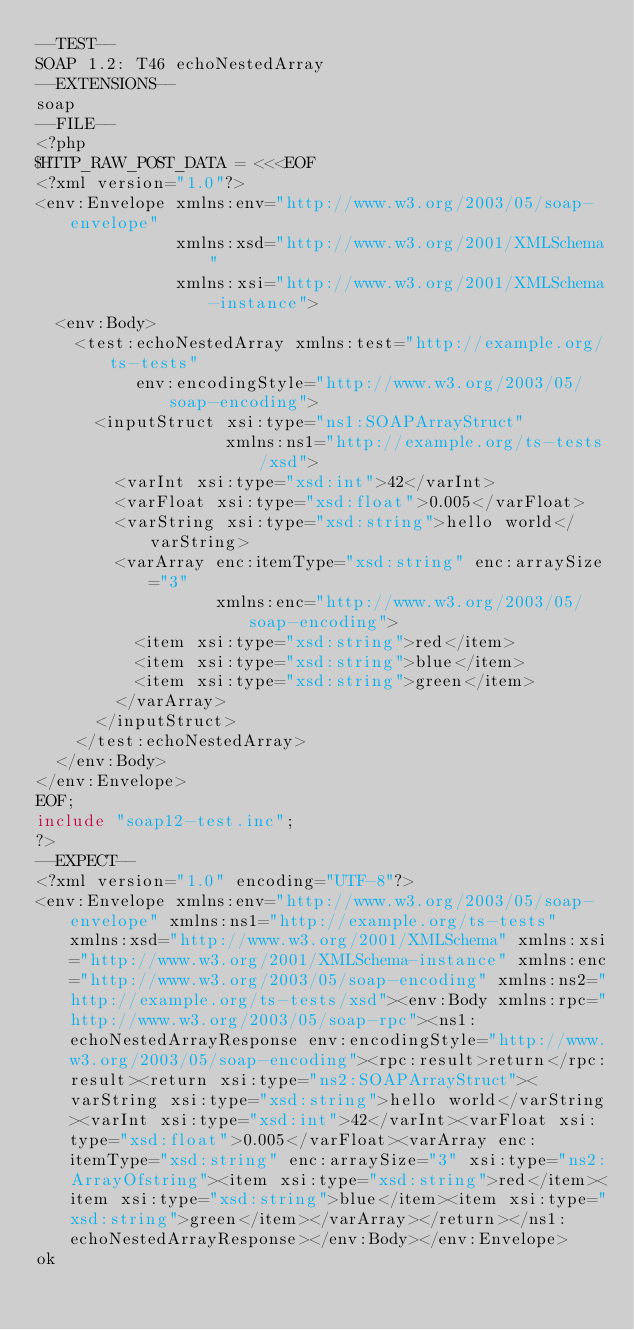<code> <loc_0><loc_0><loc_500><loc_500><_PHP_>--TEST--
SOAP 1.2: T46 echoNestedArray
--EXTENSIONS--
soap
--FILE--
<?php
$HTTP_RAW_POST_DATA = <<<EOF
<?xml version="1.0"?>
<env:Envelope xmlns:env="http://www.w3.org/2003/05/soap-envelope"
              xmlns:xsd="http://www.w3.org/2001/XMLSchema"
              xmlns:xsi="http://www.w3.org/2001/XMLSchema-instance">
  <env:Body>
    <test:echoNestedArray xmlns:test="http://example.org/ts-tests"
          env:encodingStyle="http://www.w3.org/2003/05/soap-encoding">
      <inputStruct xsi:type="ns1:SOAPArrayStruct"
                   xmlns:ns1="http://example.org/ts-tests/xsd">
        <varInt xsi:type="xsd:int">42</varInt>
        <varFloat xsi:type="xsd:float">0.005</varFloat>
        <varString xsi:type="xsd:string">hello world</varString>
        <varArray enc:itemType="xsd:string" enc:arraySize="3"
                  xmlns:enc="http://www.w3.org/2003/05/soap-encoding">
          <item xsi:type="xsd:string">red</item>
          <item xsi:type="xsd:string">blue</item>
          <item xsi:type="xsd:string">green</item>
        </varArray>
      </inputStruct>
    </test:echoNestedArray>
  </env:Body>
</env:Envelope>
EOF;
include "soap12-test.inc";
?>
--EXPECT--
<?xml version="1.0" encoding="UTF-8"?>
<env:Envelope xmlns:env="http://www.w3.org/2003/05/soap-envelope" xmlns:ns1="http://example.org/ts-tests" xmlns:xsd="http://www.w3.org/2001/XMLSchema" xmlns:xsi="http://www.w3.org/2001/XMLSchema-instance" xmlns:enc="http://www.w3.org/2003/05/soap-encoding" xmlns:ns2="http://example.org/ts-tests/xsd"><env:Body xmlns:rpc="http://www.w3.org/2003/05/soap-rpc"><ns1:echoNestedArrayResponse env:encodingStyle="http://www.w3.org/2003/05/soap-encoding"><rpc:result>return</rpc:result><return xsi:type="ns2:SOAPArrayStruct"><varString xsi:type="xsd:string">hello world</varString><varInt xsi:type="xsd:int">42</varInt><varFloat xsi:type="xsd:float">0.005</varFloat><varArray enc:itemType="xsd:string" enc:arraySize="3" xsi:type="ns2:ArrayOfstring"><item xsi:type="xsd:string">red</item><item xsi:type="xsd:string">blue</item><item xsi:type="xsd:string">green</item></varArray></return></ns1:echoNestedArrayResponse></env:Body></env:Envelope>
ok
</code> 